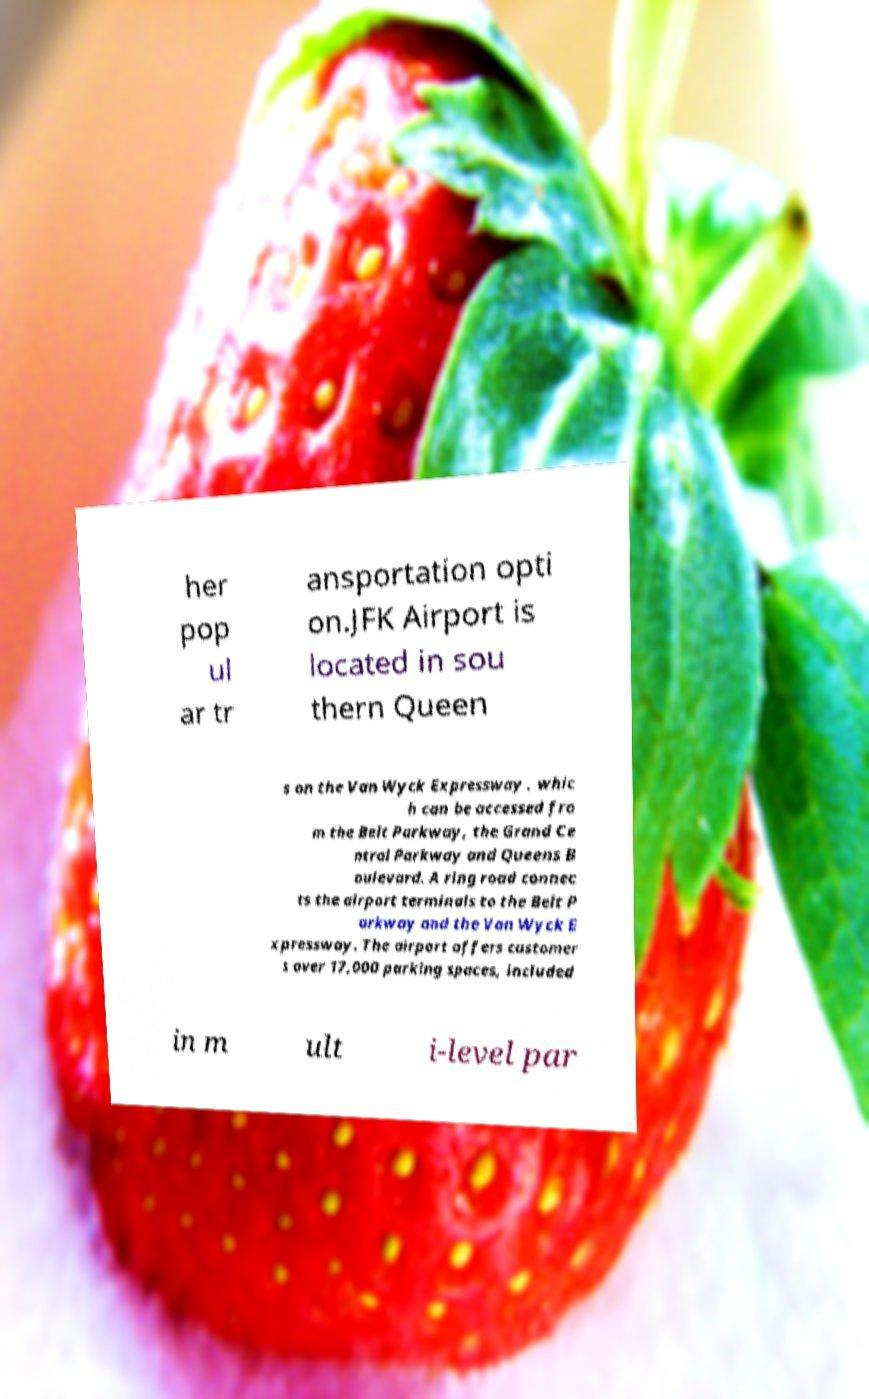Can you read and provide the text displayed in the image?This photo seems to have some interesting text. Can you extract and type it out for me? her pop ul ar tr ansportation opti on.JFK Airport is located in sou thern Queen s on the Van Wyck Expressway , whic h can be accessed fro m the Belt Parkway, the Grand Ce ntral Parkway and Queens B oulevard. A ring road connec ts the airport terminals to the Belt P arkway and the Van Wyck E xpressway. The airport offers customer s over 17,000 parking spaces, included in m ult i-level par 